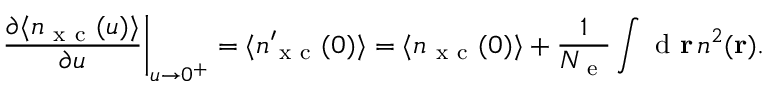Convert formula to latex. <formula><loc_0><loc_0><loc_500><loc_500>\frac { \partial \langle n _ { x c } ( u ) \rangle } { \partial u } \right | _ { u \rightarrow 0 ^ { + } } = \langle n _ { x c } ^ { \prime } ( 0 ) \rangle = \langle n _ { x c } ( 0 ) \rangle + \frac { 1 } { { N _ { e } } } \int d { r } \, n ^ { 2 } ( { r } ) .</formula> 